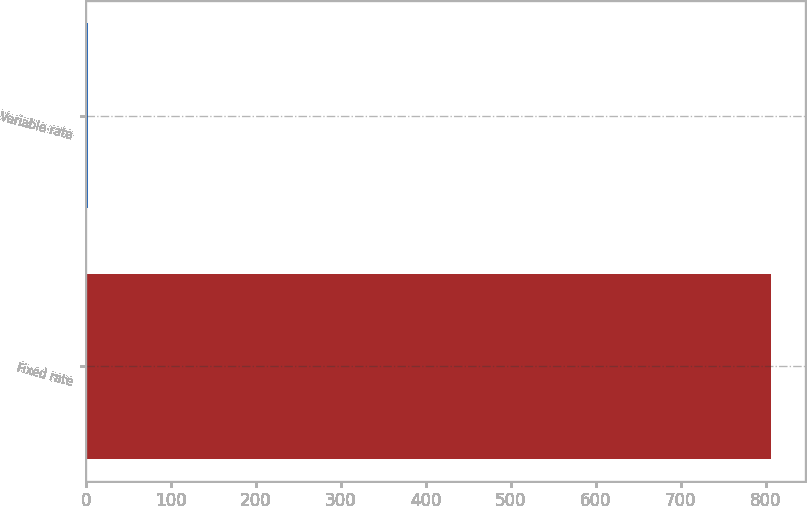Convert chart. <chart><loc_0><loc_0><loc_500><loc_500><bar_chart><fcel>Fixed rate<fcel>Variable rate<nl><fcel>806.4<fcel>2.4<nl></chart> 